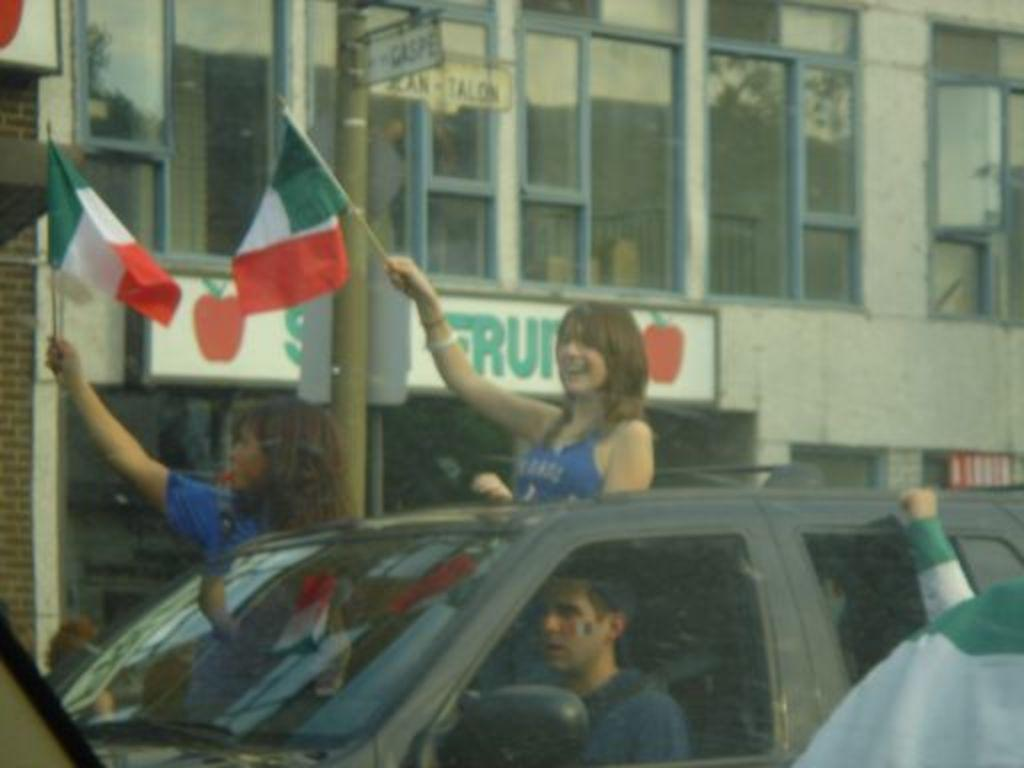What is the main subject of the image? The main subject of the image is a car. What are the people in the car doing? The people are sitting and standing in the car. What are the people holding in the image? The people are holding a flag. Who is the expert sitting on the throne in the image? There is no expert or throne present in the image; it features a car with people holding a flag. 